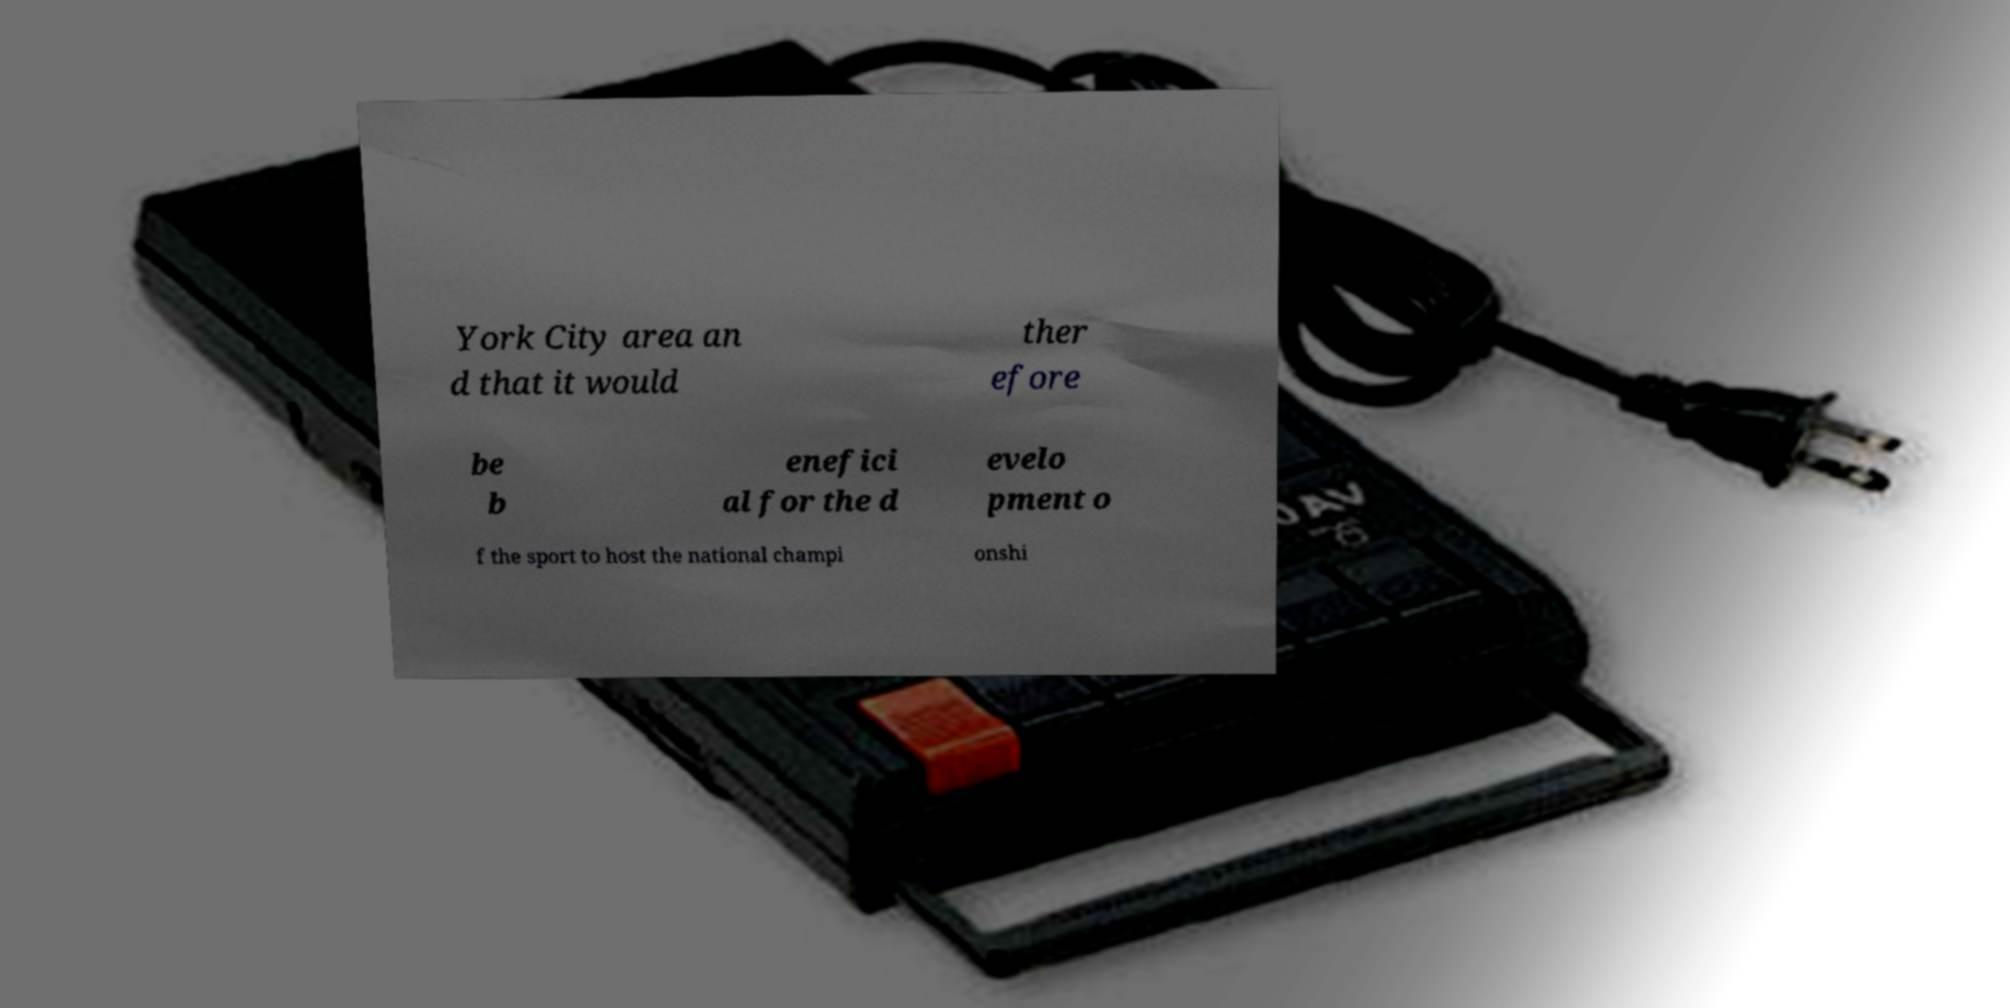Could you assist in decoding the text presented in this image and type it out clearly? York City area an d that it would ther efore be b enefici al for the d evelo pment o f the sport to host the national champi onshi 